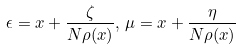Convert formula to latex. <formula><loc_0><loc_0><loc_500><loc_500>\epsilon = x + \frac { \zeta } { N \rho ( x ) } , \, \mu = x + \frac { \eta } { N \rho ( x ) }</formula> 